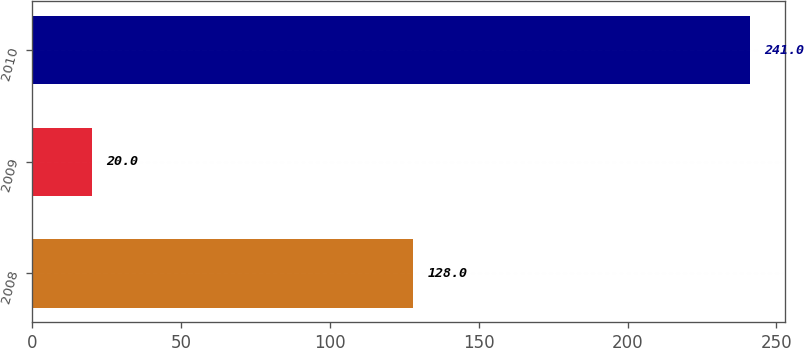<chart> <loc_0><loc_0><loc_500><loc_500><bar_chart><fcel>2008<fcel>2009<fcel>2010<nl><fcel>128<fcel>20<fcel>241<nl></chart> 